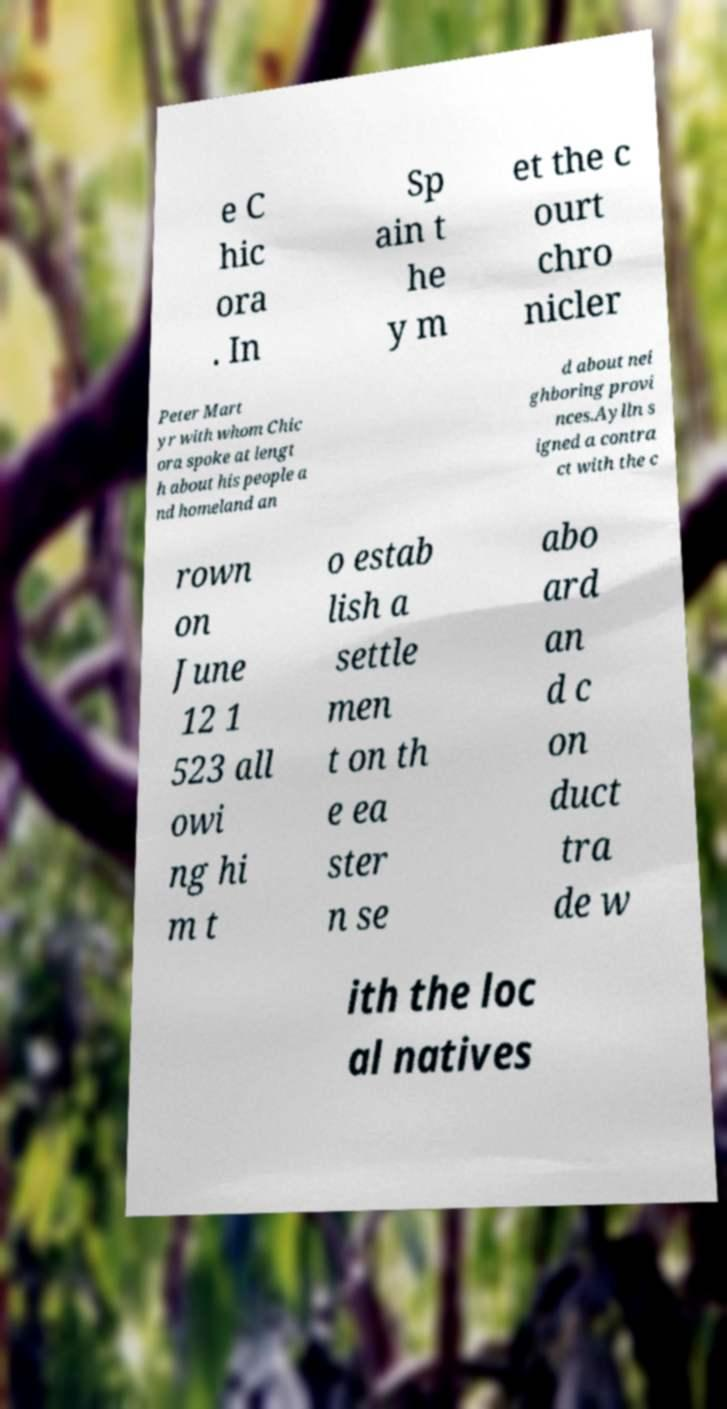Please read and relay the text visible in this image. What does it say? e C hic ora . In Sp ain t he y m et the c ourt chro nicler Peter Mart yr with whom Chic ora spoke at lengt h about his people a nd homeland an d about nei ghboring provi nces.Aylln s igned a contra ct with the c rown on June 12 1 523 all owi ng hi m t o estab lish a settle men t on th e ea ster n se abo ard an d c on duct tra de w ith the loc al natives 